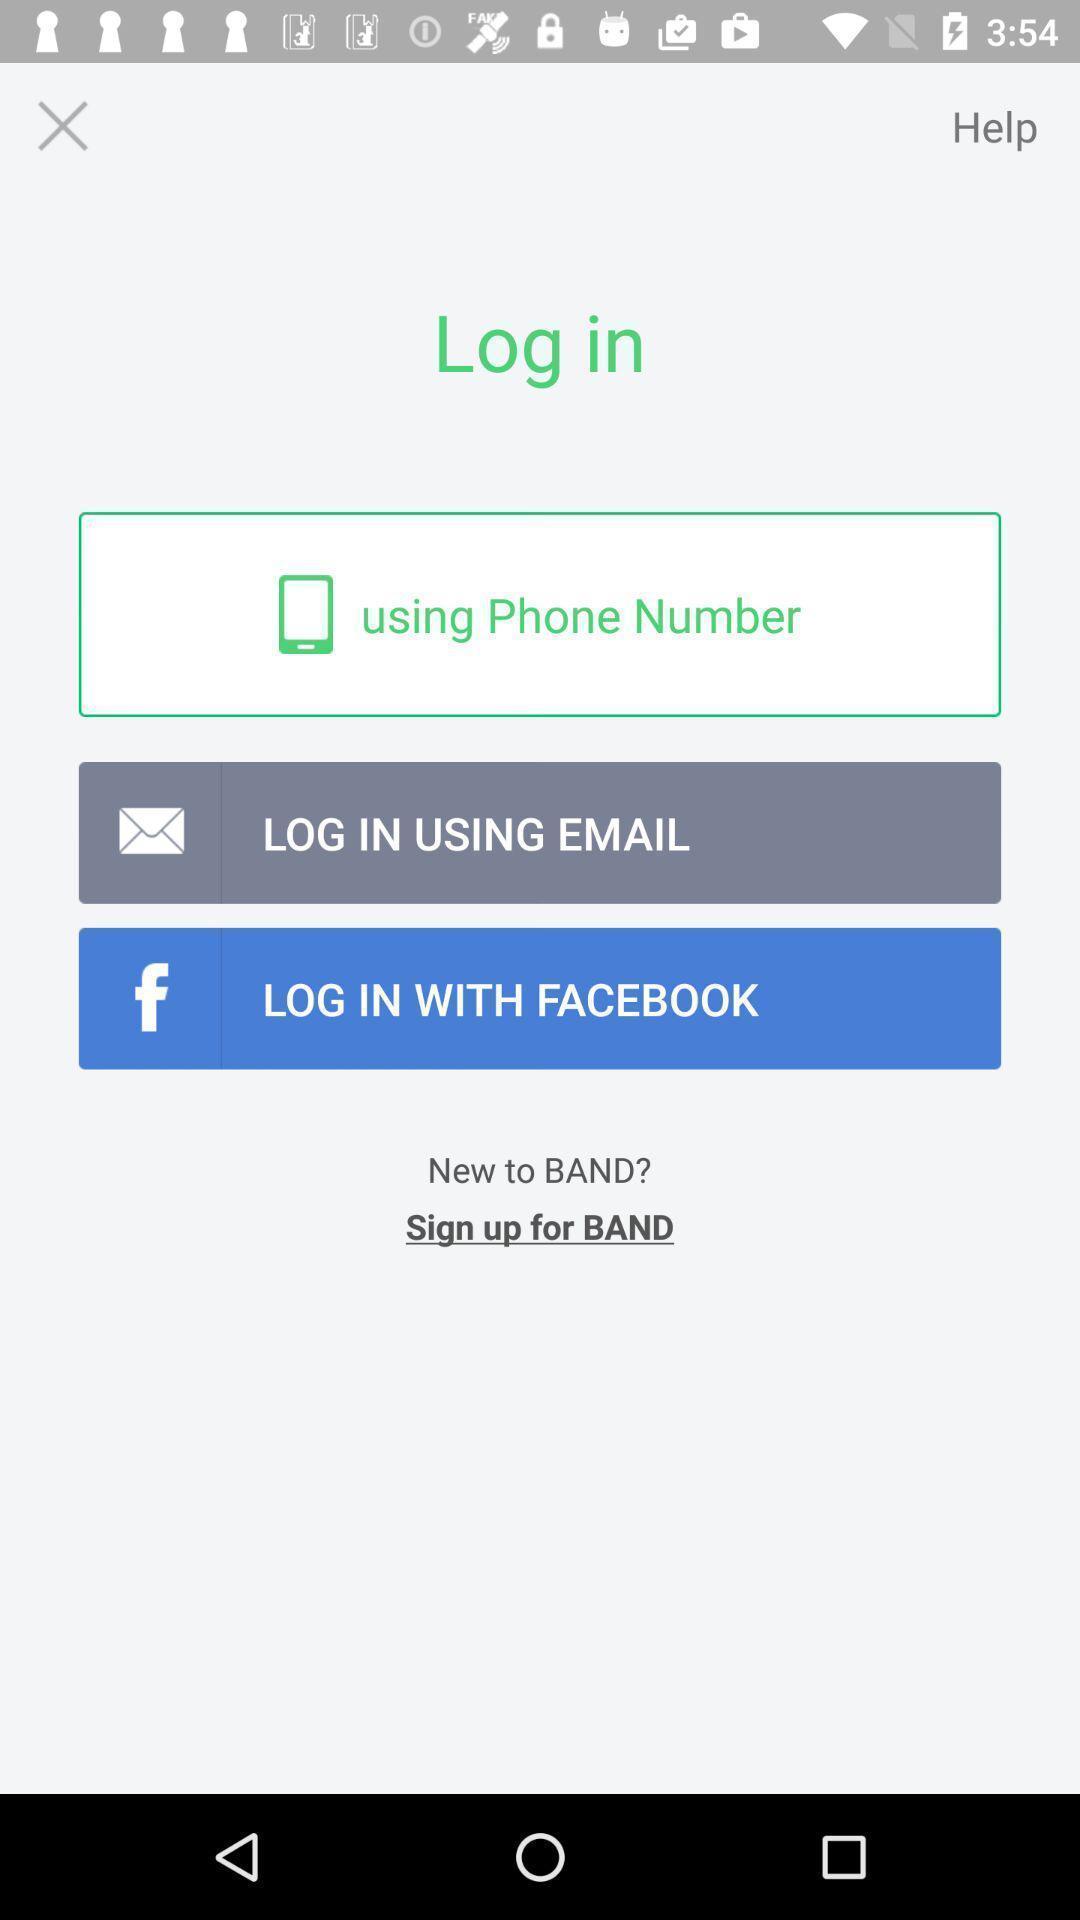Provide a detailed account of this screenshot. Screen displaying the login page. 